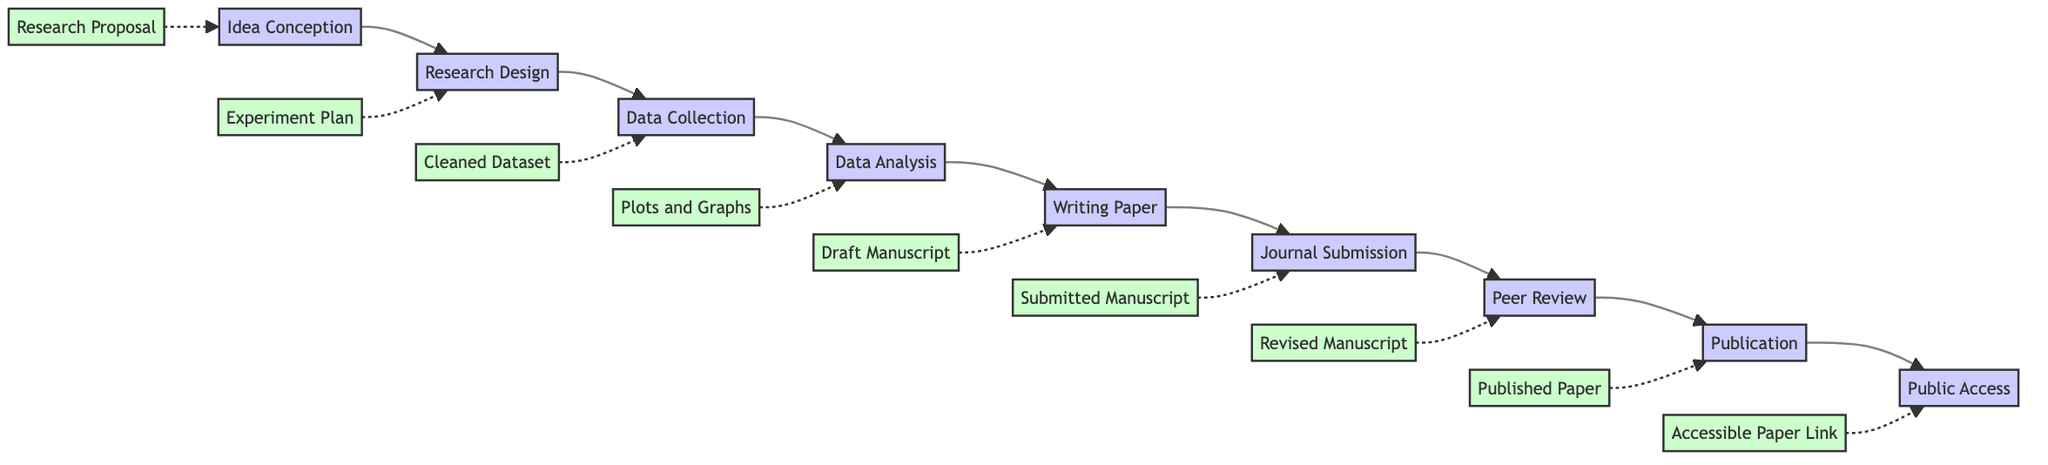What is the first stage in the research paper publication process? The diagram identifies "Idea Conception" as the first node in the flowchart, marking the starting point of the process.
Answer: Idea Conception How many stages are there in total? The diagram shows a sequence of eight stages, listed as nodes from "Idea Conception" to "Public Access." By counting these nodes, we find there are eight.
Answer: Eight What is the output of the "Writing the Paper" stage? The diagram indicates that the output for the "Writing the Paper" stage is the "Draft Manuscript," which is connected by a dashed line to the corresponding stage.
Answer: Draft Manuscript Which stage comes directly after "Data Analysis"? Following the flowchart from "Data Analysis," the next connected stage is "Writing the Paper," making it the immediate successor in the process.
Answer: Writing the Paper What tools are used in the "Peer Review Process"? The diagram lists the tools associated with the "Peer Review Process" as "Manuscript Tracking System," "Referencing Software," and "MS Word," which can be identified as inputs at that stage.
Answer: Manuscript Tracking System, Referencing Software, MS Word What is the output of the "Data Collection" stage? In the flowchart, "Cleaned Dataset" is marked as the output of the "Data Collection" stage, indicating what is produced after completing that stage.
Answer: Cleaned Dataset Which two stages are connected by a dashed line to denote outputs? The stages "Idea Conception" and "Public Access" both have associated outputs represented by dashed lines leading to "Research Proposal" and "Accessible Paper Link," respectively.
Answer: Idea Conception, Public Access Name a tool used in the "Research Design and Planning" stage. The diagram shows three tools listed for "Research Design and Planning," one of which is "Trello," providing a specific example.
Answer: Trello Which stage requires addressing reviewer’s comments? The flowchart indicates that the "Peer Review Process" is the stage where addressing reviewer's comments is necessary, as shown in the task list for that process.
Answer: Peer Review Process 